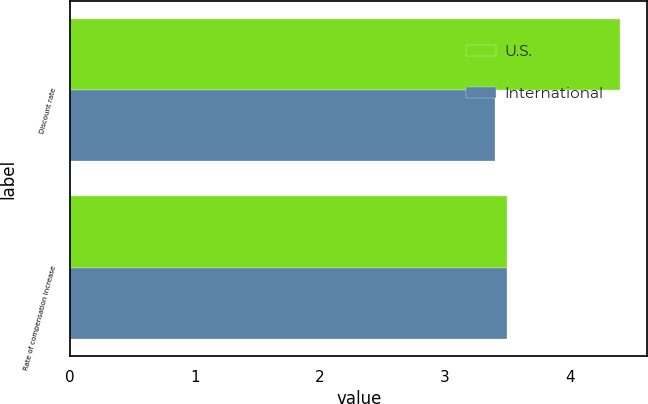<chart> <loc_0><loc_0><loc_500><loc_500><stacked_bar_chart><ecel><fcel>Discount rate<fcel>Rate of compensation increase<nl><fcel>U.S.<fcel>4.4<fcel>3.5<nl><fcel>International<fcel>3.4<fcel>3.5<nl></chart> 